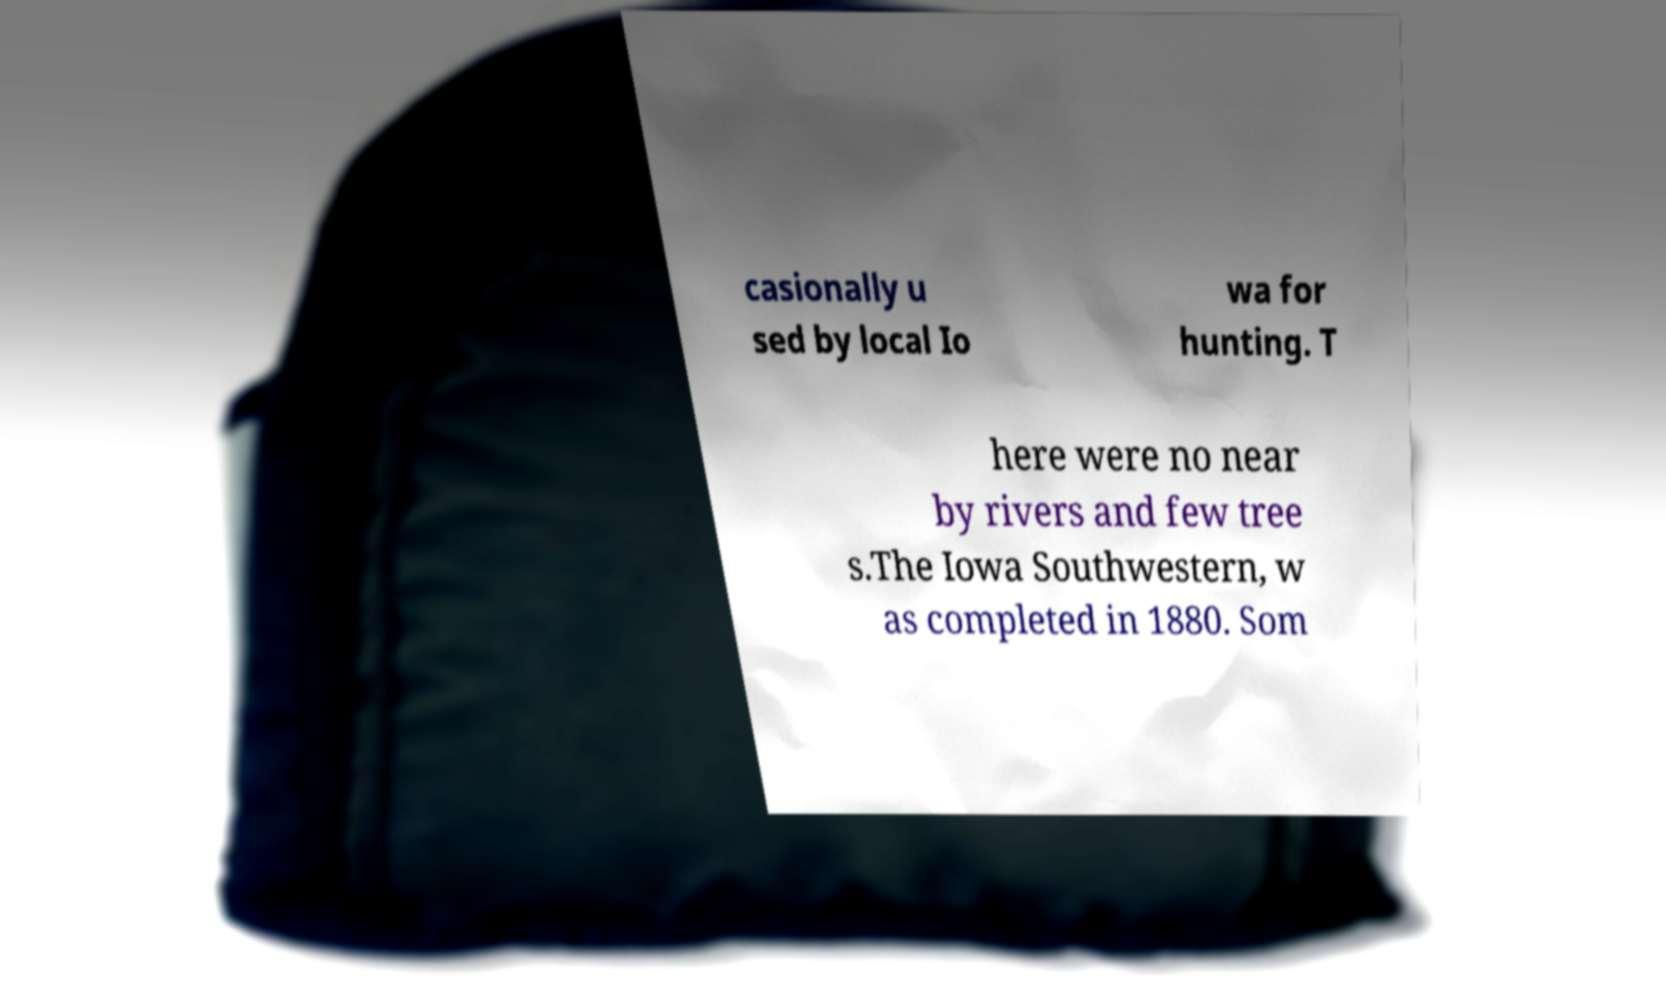I need the written content from this picture converted into text. Can you do that? casionally u sed by local Io wa for hunting. T here were no near by rivers and few tree s.The Iowa Southwestern, w as completed in 1880. Som 